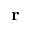<formula> <loc_0><loc_0><loc_500><loc_500>r</formula> 